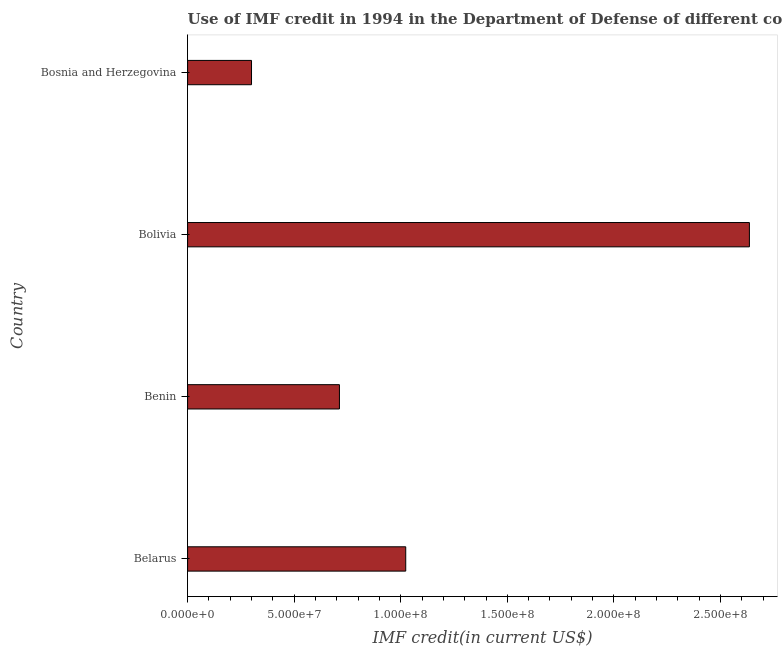Does the graph contain grids?
Keep it short and to the point. No. What is the title of the graph?
Give a very brief answer. Use of IMF credit in 1994 in the Department of Defense of different countries. What is the label or title of the X-axis?
Provide a short and direct response. IMF credit(in current US$). What is the label or title of the Y-axis?
Offer a terse response. Country. What is the use of imf credit in dod in Belarus?
Offer a very short reply. 1.02e+08. Across all countries, what is the maximum use of imf credit in dod?
Keep it short and to the point. 2.64e+08. Across all countries, what is the minimum use of imf credit in dod?
Keep it short and to the point. 3.00e+07. In which country was the use of imf credit in dod minimum?
Keep it short and to the point. Bosnia and Herzegovina. What is the sum of the use of imf credit in dod?
Keep it short and to the point. 4.67e+08. What is the difference between the use of imf credit in dod in Belarus and Bolivia?
Your answer should be compact. -1.61e+08. What is the average use of imf credit in dod per country?
Offer a very short reply. 1.17e+08. What is the median use of imf credit in dod?
Your answer should be compact. 8.68e+07. What is the ratio of the use of imf credit in dod in Belarus to that in Bosnia and Herzegovina?
Provide a short and direct response. 3.41. Is the use of imf credit in dod in Benin less than that in Bosnia and Herzegovina?
Keep it short and to the point. No. What is the difference between the highest and the second highest use of imf credit in dod?
Give a very brief answer. 1.61e+08. Is the sum of the use of imf credit in dod in Belarus and Bolivia greater than the maximum use of imf credit in dod across all countries?
Give a very brief answer. Yes. What is the difference between the highest and the lowest use of imf credit in dod?
Your answer should be very brief. 2.34e+08. In how many countries, is the use of imf credit in dod greater than the average use of imf credit in dod taken over all countries?
Provide a succinct answer. 1. How many countries are there in the graph?
Offer a very short reply. 4. What is the difference between two consecutive major ticks on the X-axis?
Keep it short and to the point. 5.00e+07. What is the IMF credit(in current US$) in Belarus?
Provide a succinct answer. 1.02e+08. What is the IMF credit(in current US$) in Benin?
Keep it short and to the point. 7.12e+07. What is the IMF credit(in current US$) in Bolivia?
Give a very brief answer. 2.64e+08. What is the IMF credit(in current US$) in Bosnia and Herzegovina?
Make the answer very short. 3.00e+07. What is the difference between the IMF credit(in current US$) in Belarus and Benin?
Your response must be concise. 3.11e+07. What is the difference between the IMF credit(in current US$) in Belarus and Bolivia?
Your response must be concise. -1.61e+08. What is the difference between the IMF credit(in current US$) in Belarus and Bosnia and Herzegovina?
Offer a terse response. 7.24e+07. What is the difference between the IMF credit(in current US$) in Benin and Bolivia?
Offer a terse response. -1.92e+08. What is the difference between the IMF credit(in current US$) in Benin and Bosnia and Herzegovina?
Provide a succinct answer. 4.12e+07. What is the difference between the IMF credit(in current US$) in Bolivia and Bosnia and Herzegovina?
Ensure brevity in your answer.  2.34e+08. What is the ratio of the IMF credit(in current US$) in Belarus to that in Benin?
Give a very brief answer. 1.44. What is the ratio of the IMF credit(in current US$) in Belarus to that in Bolivia?
Your response must be concise. 0.39. What is the ratio of the IMF credit(in current US$) in Belarus to that in Bosnia and Herzegovina?
Your answer should be compact. 3.41. What is the ratio of the IMF credit(in current US$) in Benin to that in Bolivia?
Ensure brevity in your answer.  0.27. What is the ratio of the IMF credit(in current US$) in Benin to that in Bosnia and Herzegovina?
Your answer should be very brief. 2.38. What is the ratio of the IMF credit(in current US$) in Bolivia to that in Bosnia and Herzegovina?
Provide a short and direct response. 8.79. 